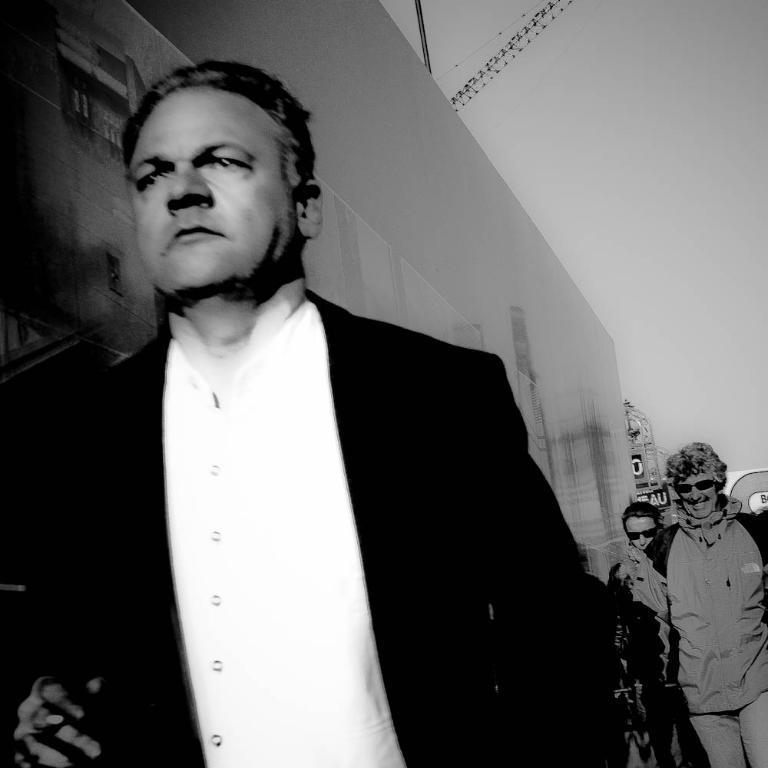Can you describe this image briefly? This is a black and white image. At the bottom, I can see few people. In the background there is a wall. At the top of the image I can see the sky. 